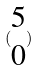Convert formula to latex. <formula><loc_0><loc_0><loc_500><loc_500>( \begin{matrix} 5 \\ 0 \end{matrix} )</formula> 